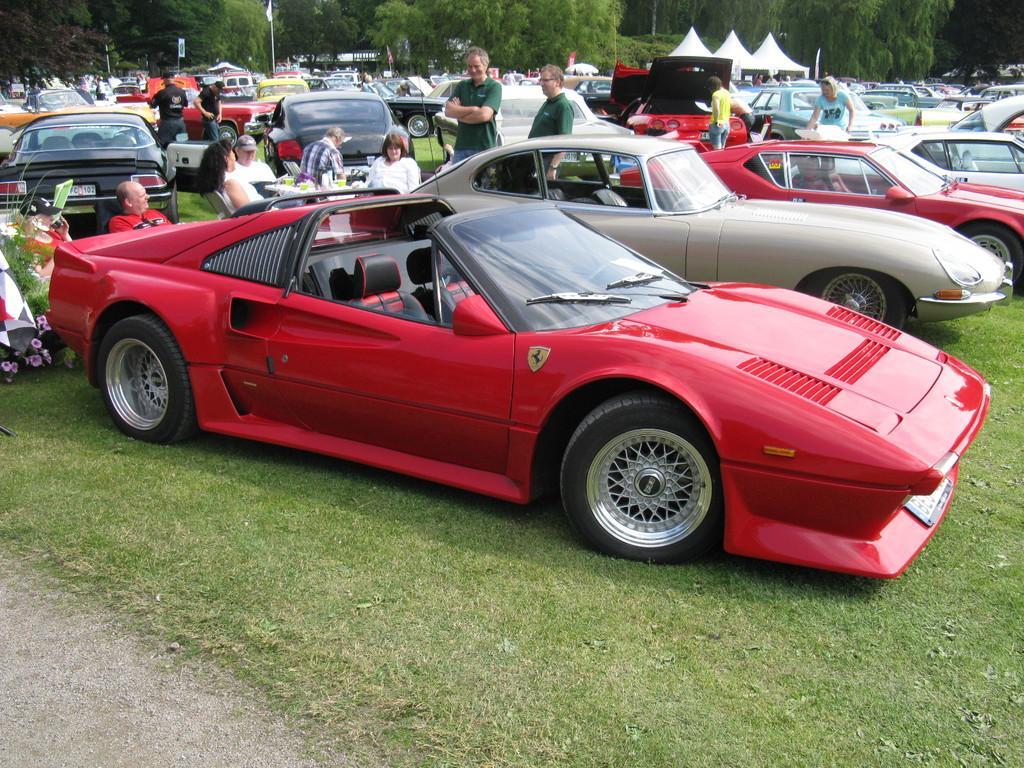What type of vehicles can be seen on the ground in the image? There are cars on the ground in the image. What are the people in the image doing? Some people are sitting on chairs, while others are standing in the image. What can be seen in the background of the image? There are tents and trees in the background of the image. What time of day is it in the image, and how many slaves are present? The time of day is not mentioned in the image, and there is no indication of any slaves being present. Can you describe the tray that is being used by the people in the image? There is no tray visible in the image. 